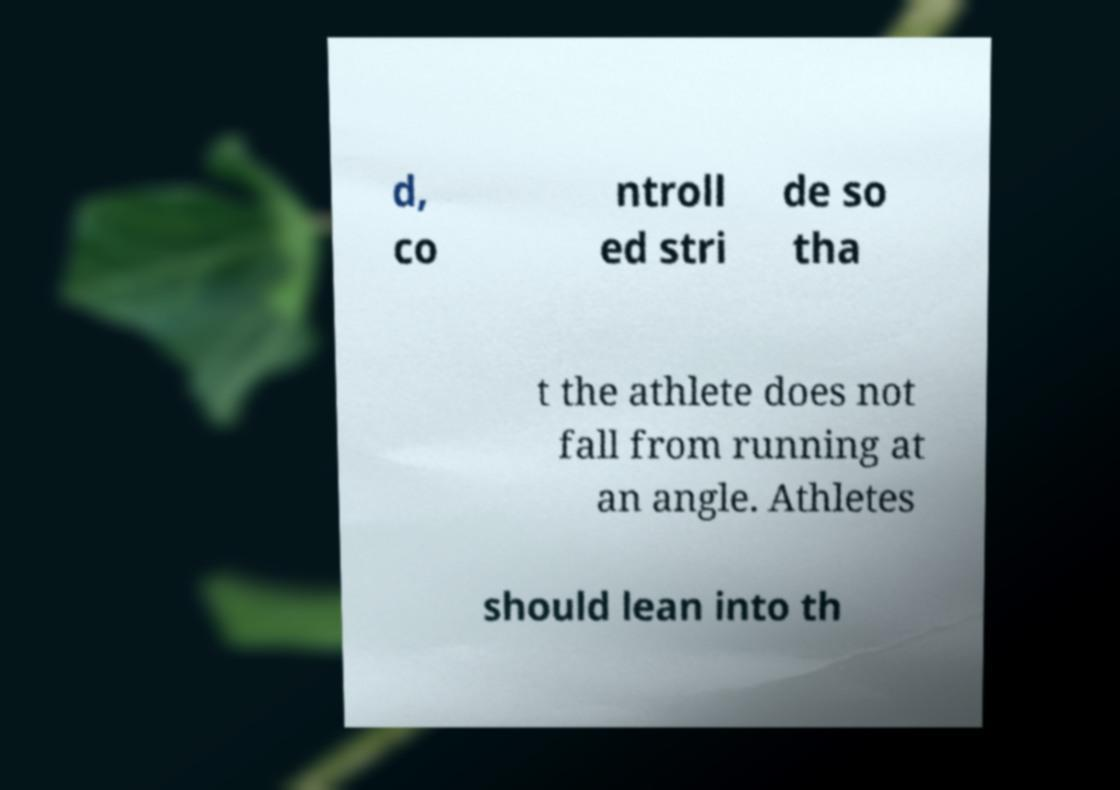What messages or text are displayed in this image? I need them in a readable, typed format. d, co ntroll ed stri de so tha t the athlete does not fall from running at an angle. Athletes should lean into th 